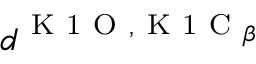Convert formula to latex. <formula><loc_0><loc_0><loc_500><loc_500>d ^ { K 1 O , K 1 C _ { \beta } }</formula> 